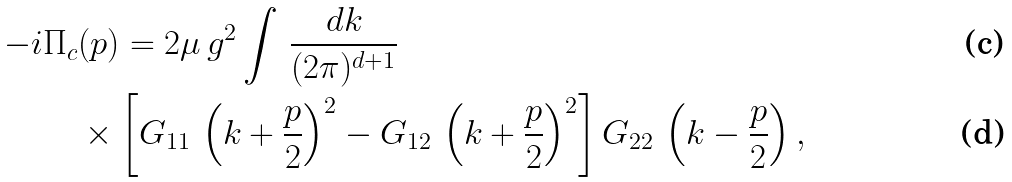<formula> <loc_0><loc_0><loc_500><loc_500>- i & \Pi _ { c } ( p ) = 2 \mu \, g ^ { 2 } \int \, \frac { d k } { ( 2 \pi ) ^ { d + 1 } } \\ & \quad \times \left [ G _ { 1 1 } \, \left ( k + \frac { p } { 2 } \right ) ^ { 2 } - G _ { 1 2 } \, \left ( k + \frac { p } { 2 } \right ) ^ { 2 } \right ] G _ { 2 2 } \, \left ( k - \frac { p } { 2 } \right ) ,</formula> 